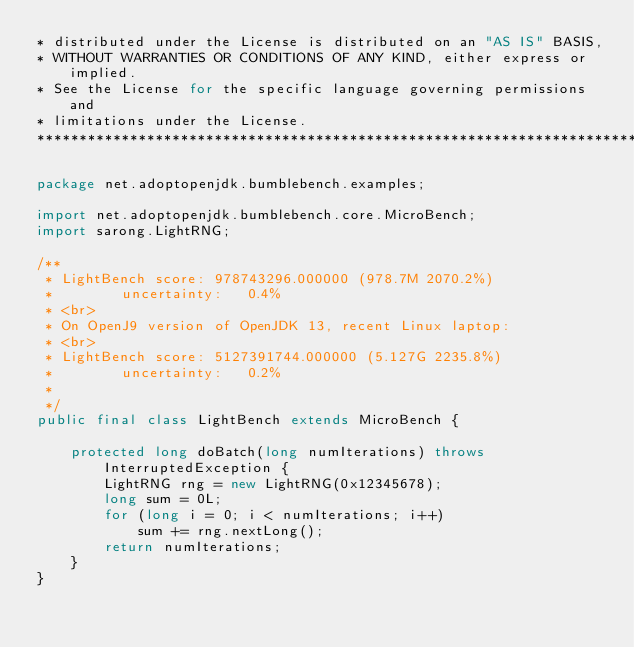Convert code to text. <code><loc_0><loc_0><loc_500><loc_500><_Java_>* distributed under the License is distributed on an "AS IS" BASIS,
* WITHOUT WARRANTIES OR CONDITIONS OF ANY KIND, either express or implied.
* See the License for the specific language governing permissions and
* limitations under the License.
*******************************************************************************/

package net.adoptopenjdk.bumblebench.examples;

import net.adoptopenjdk.bumblebench.core.MicroBench;
import sarong.LightRNG;

/**
 * LightBench score: 978743296.000000 (978.7M 2070.2%)
 *        uncertainty:   0.4%
 * <br>
 * On OpenJ9 version of OpenJDK 13, recent Linux laptop:
 * <br>
 * LightBench score: 5127391744.000000 (5.127G 2235.8%)
 *        uncertainty:   0.2%
 *
 */
public final class LightBench extends MicroBench {

	protected long doBatch(long numIterations) throws InterruptedException {
		LightRNG rng = new LightRNG(0x12345678);
		long sum = 0L;
		for (long i = 0; i < numIterations; i++)
			sum += rng.nextLong();
		return numIterations;
	}
}

</code> 